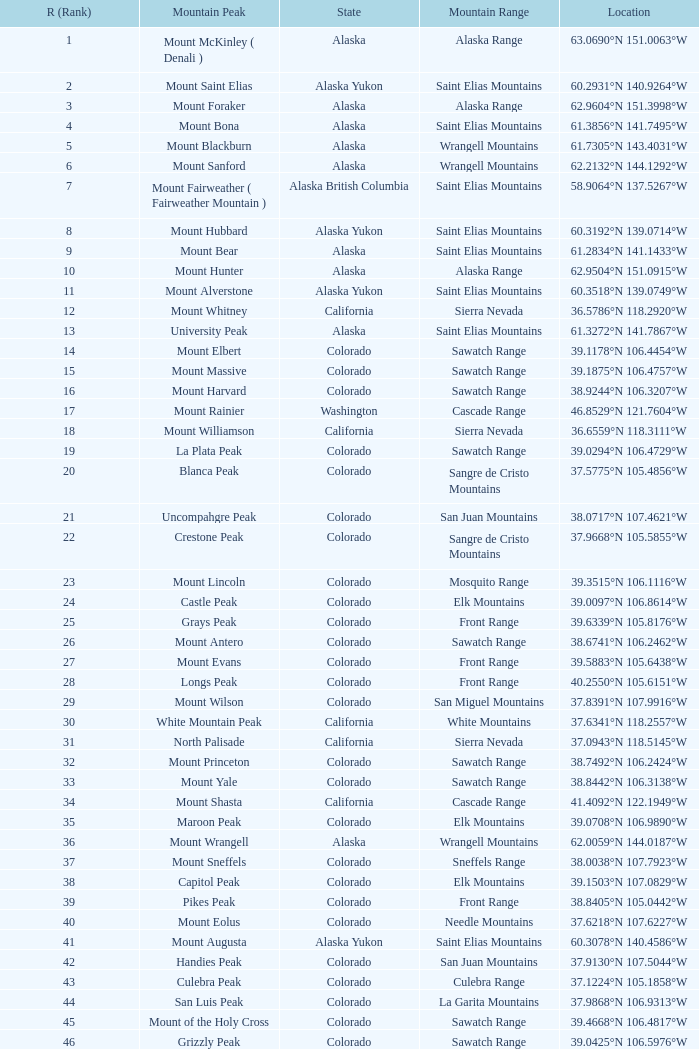What is the standing when the state is colorado and the place is 3 83.0. 